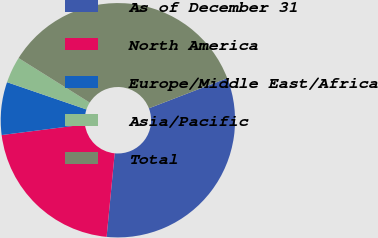Convert chart to OTSL. <chart><loc_0><loc_0><loc_500><loc_500><pie_chart><fcel>As of December 31<fcel>North America<fcel>Europe/Middle East/Africa<fcel>Asia/Pacific<fcel>Total<nl><fcel>32.38%<fcel>21.45%<fcel>7.28%<fcel>3.64%<fcel>35.25%<nl></chart> 